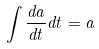<formula> <loc_0><loc_0><loc_500><loc_500>\int \frac { d a } { d t } d t = a</formula> 